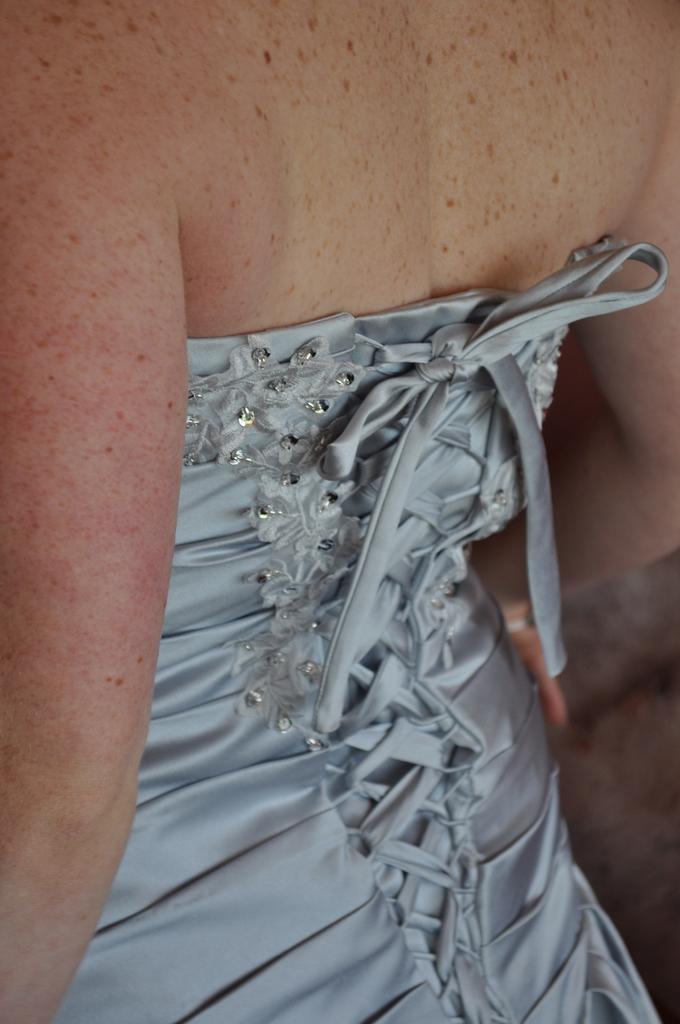Please provide a concise description of this image. In this image we can see the body of a person. 